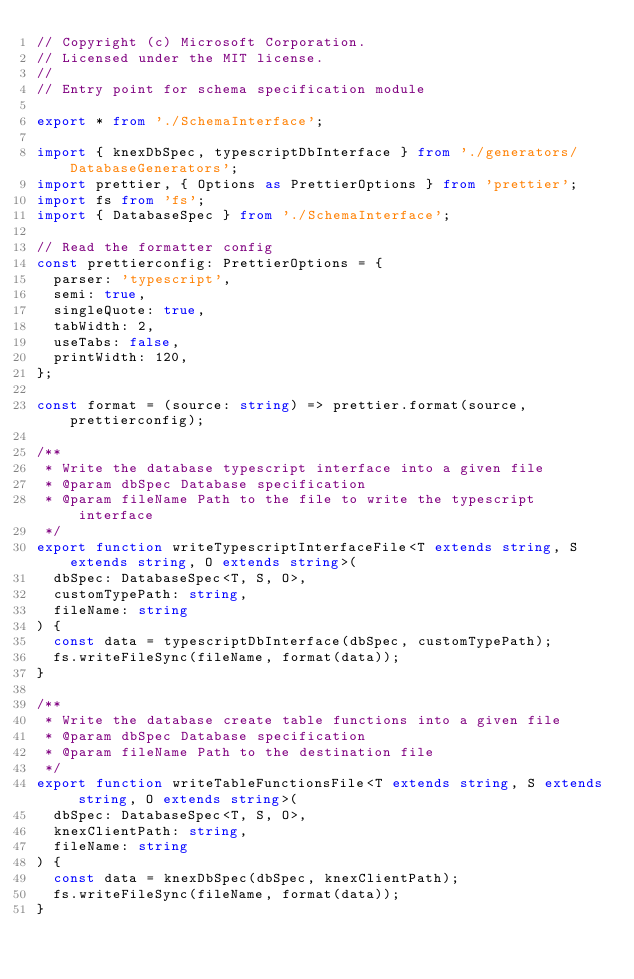<code> <loc_0><loc_0><loc_500><loc_500><_TypeScript_>// Copyright (c) Microsoft Corporation.
// Licensed under the MIT license.
//
// Entry point for schema specification module

export * from './SchemaInterface';

import { knexDbSpec, typescriptDbInterface } from './generators/DatabaseGenerators';
import prettier, { Options as PrettierOptions } from 'prettier';
import fs from 'fs';
import { DatabaseSpec } from './SchemaInterface';

// Read the formatter config
const prettierconfig: PrettierOptions = {
  parser: 'typescript',
  semi: true,
  singleQuote: true,
  tabWidth: 2,
  useTabs: false,
  printWidth: 120,
};

const format = (source: string) => prettier.format(source, prettierconfig);

/**
 * Write the database typescript interface into a given file
 * @param dbSpec Database specification
 * @param fileName Path to the file to write the typescript interface
 */
export function writeTypescriptInterfaceFile<T extends string, S extends string, O extends string>(
  dbSpec: DatabaseSpec<T, S, O>,
  customTypePath: string,
  fileName: string
) {
  const data = typescriptDbInterface(dbSpec, customTypePath);
  fs.writeFileSync(fileName, format(data));
}

/**
 * Write the database create table functions into a given file
 * @param dbSpec Database specification
 * @param fileName Path to the destination file
 */
export function writeTableFunctionsFile<T extends string, S extends string, O extends string>(
  dbSpec: DatabaseSpec<T, S, O>,
  knexClientPath: string,
  fileName: string
) {
  const data = knexDbSpec(dbSpec, knexClientPath);
  fs.writeFileSync(fileName, format(data));
}
</code> 